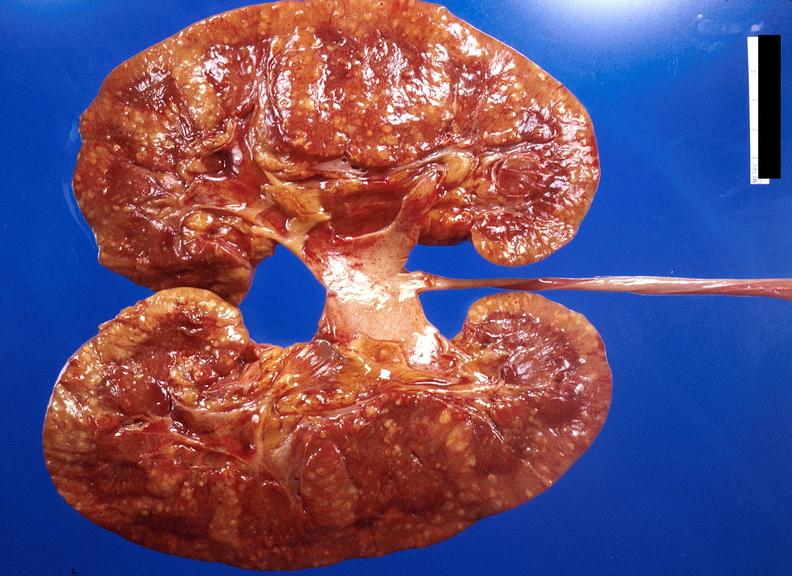what does this image show?
Answer the question using a single word or phrase. Kidney 